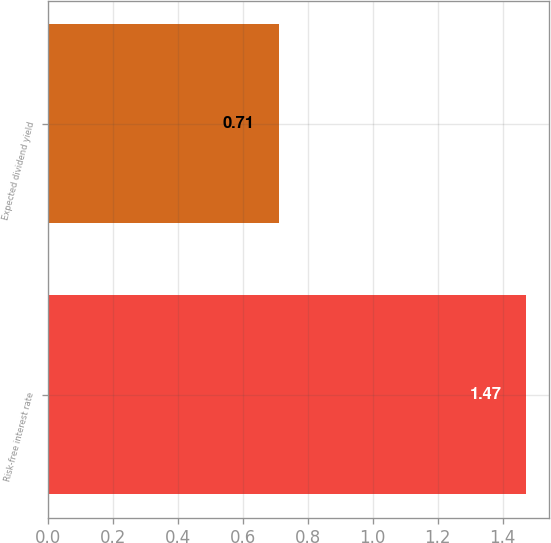Convert chart to OTSL. <chart><loc_0><loc_0><loc_500><loc_500><bar_chart><fcel>Risk-free interest rate<fcel>Expected dividend yield<nl><fcel>1.47<fcel>0.71<nl></chart> 